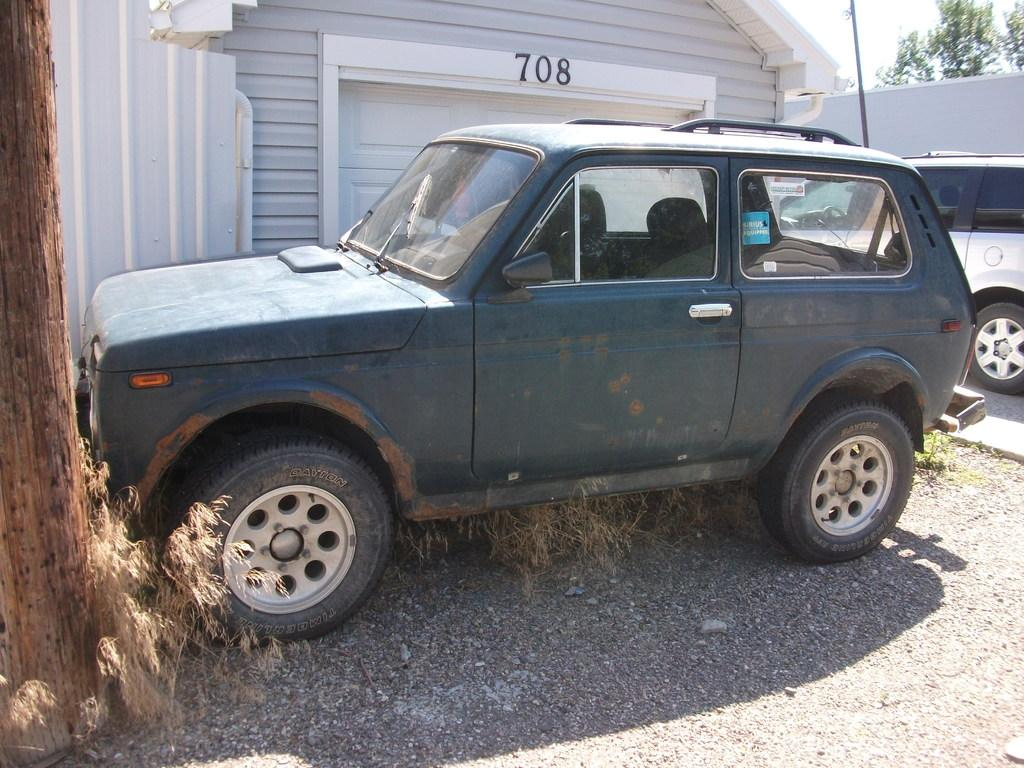<image>
Share a concise interpretation of the image provided. A dark blue jeep parked in front of a garage with 708 above it. 